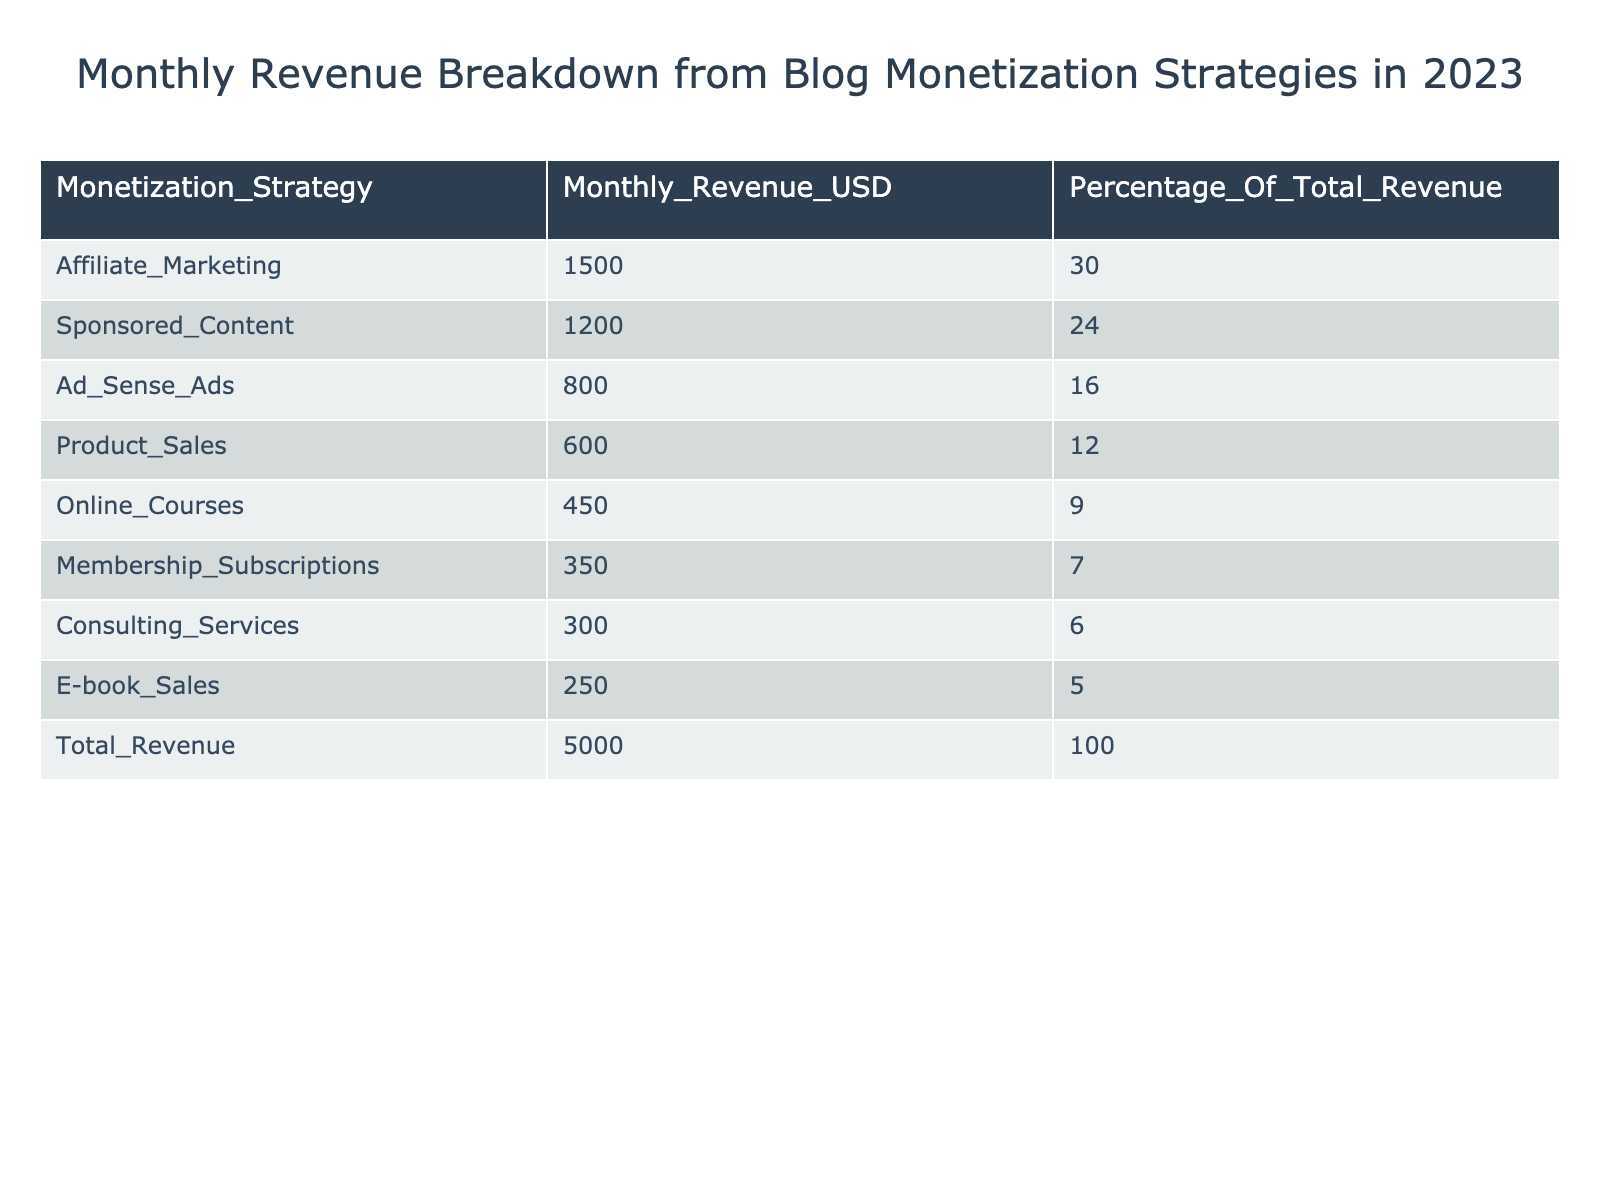What's the total revenue generated from all monetization strategies? The total revenue is directly provided in the table under the 'Total_Revenue' row, which shows a value of 5000 USD.
Answer: 5000 USD Which monetization strategy generated the highest revenue? The highest revenue is shown in the 'Monthly_Revenue_USD' column, where 'Affiliate_Marketing' has the highest value of 1500 USD.
Answer: Affiliate Marketing What percentage of the total revenue does sponsored content account for? The table specifies that 'Sponsored_Content' corresponds to 1200 USD, and it also shows this is 24% of the total revenue, defined in the 'Percentage_Of_Total_Revenue' column.
Answer: 24% How much more revenue did affiliate marketing generate compared to online courses? From the table, affiliate marketing has 1500 USD and online courses have 450 USD. Calculating the difference gives 1500 - 450 = 1050 USD.
Answer: 1050 USD Is the membership subscriptions strategy responsible for more than 5% of the total revenue? The table indicates that 'Membership_Subscriptions' accounts for 7%, which is indeed more than 5%.
Answer: Yes What is the combined revenue from product sales and e-book sales? According to the table, 'Product_Sales' generates 600 USD and 'E-book_Sales' generates 250 USD. Adding these two figures gives 600 + 250 = 850 USD.
Answer: 850 USD Which two strategies together account for at least half of the total revenue? The combined revenue for 'Affiliate_Marketing' (1500 USD) and 'Sponsored_Content' (1200 USD) totals 2700 USD, which is 54% of the total revenue. They account for more than half when added together.
Answer: Yes What is the average revenue generated by the seven monetization strategies listed, excluding the total? The total revenue from the seven strategies is calculated as 1500 + 1200 + 800 + 600 + 450 + 350 + 300 + 250 = 4150 USD across seven strategies. The average is then 4150 / 7 = approximately 592.86 USD.
Answer: Approximately 592.86 USD Which strategy accounts for the lowest revenue? In the table, 'E-book_Sales' generates the lowest revenue at 250 USD, as it is the smallest value in the 'Monthly_Revenue_USD' column.
Answer: E-book Sales 